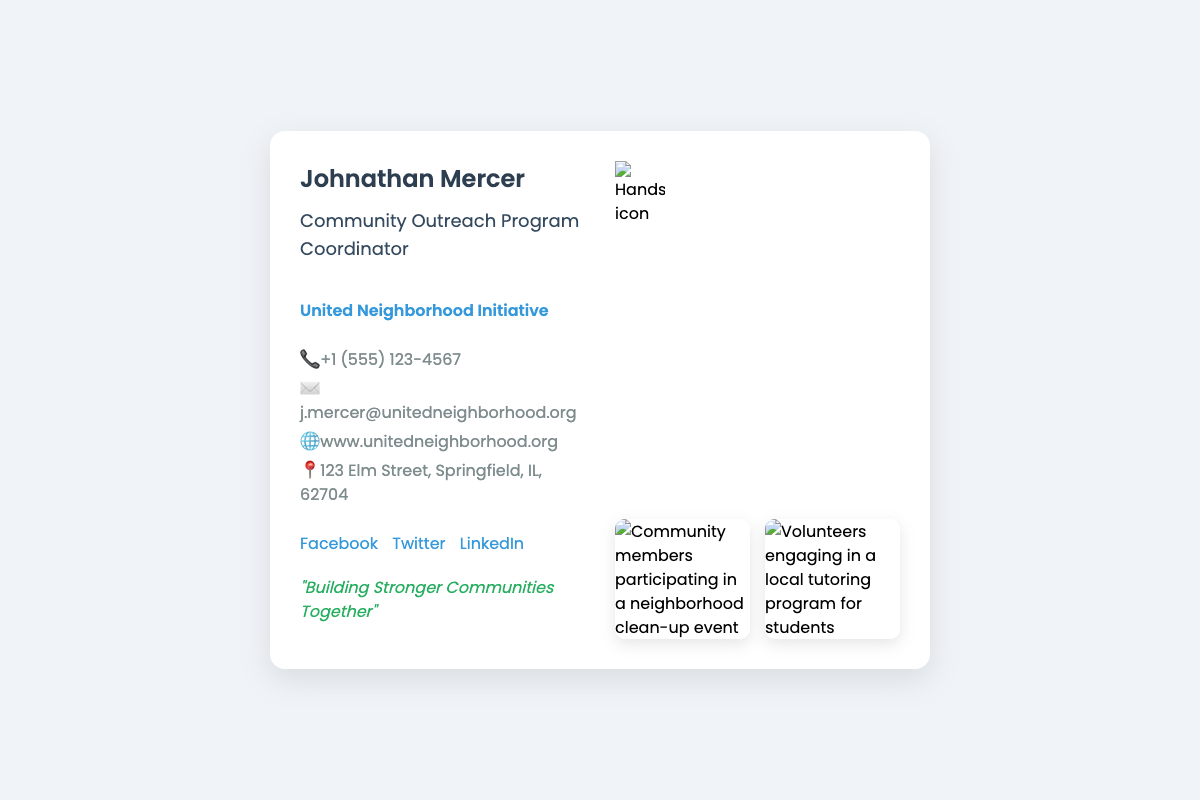What is the name of the Community Outreach Program Coordinator? The name listed on the business card is Johnathan Mercer.
Answer: Johnathan Mercer What is the organization associated with Johnathan Mercer? The organization on the business card is United Neighborhood Initiative.
Answer: United Neighborhood Initiative What is the phone number provided? The document includes a contact phone number +1 (555) 123-4567.
Answer: +1 (555) 123-4567 What is the motto mentioned on the business card? The motto found on the card is "Building Stronger Communities Together".
Answer: "Building Stronger Communities Together" How many visuals are displayed on the business card? There are two visuals related to community engagement activities shown on the card.
Answer: Two What social media platforms are linked on the card? The business card provides links to Facebook, Twitter, and LinkedIn.
Answer: Facebook, Twitter, LinkedIn What is the address listed on the business card? The address provided is 123 Elm Street, Springfield, IL, 62704.
Answer: 123 Elm Street, Springfield, IL, 62704 What type of activities are shown in the visuals? The visuals depict activities related to a neighborhood clean-up event and a local tutoring program for students.
Answer: Clean-up event and tutoring program Which phrase represents Johnathan Mercer’s role? The title noted is Community Outreach Program Coordinator.
Answer: Community Outreach Program Coordinator 